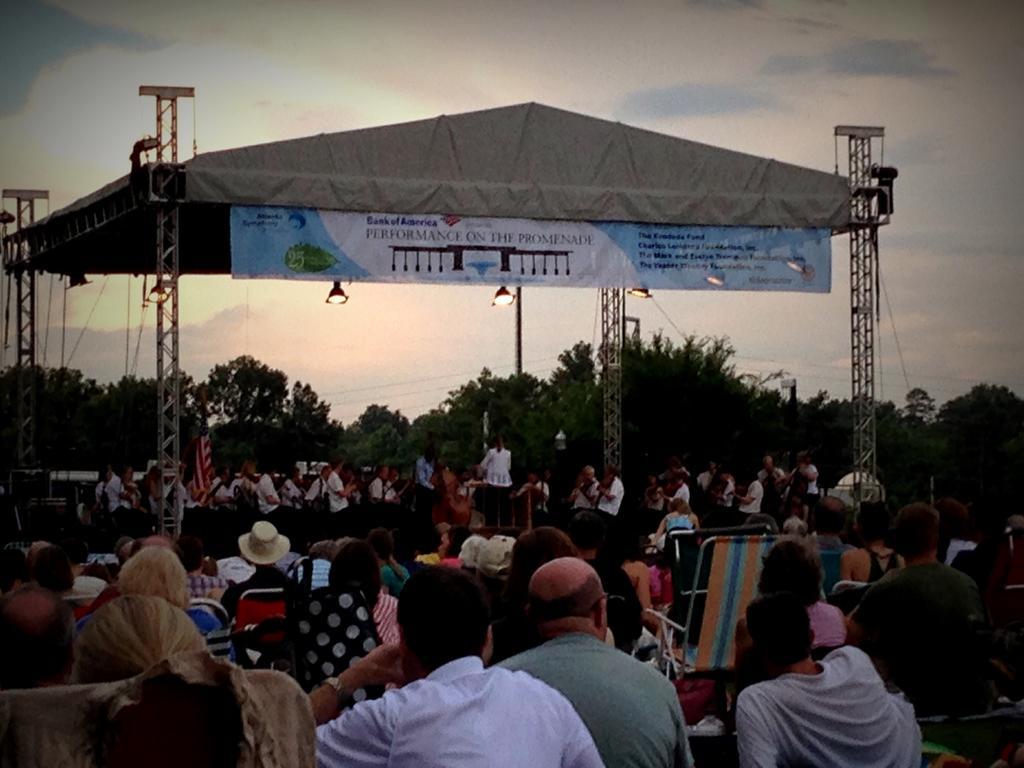Please provide a concise description of this image. In this picture few people seated on the chairs and I can see few people standing on the dais and I can see a banner with some text on it and few lights and trees and a cloudy Sky. 